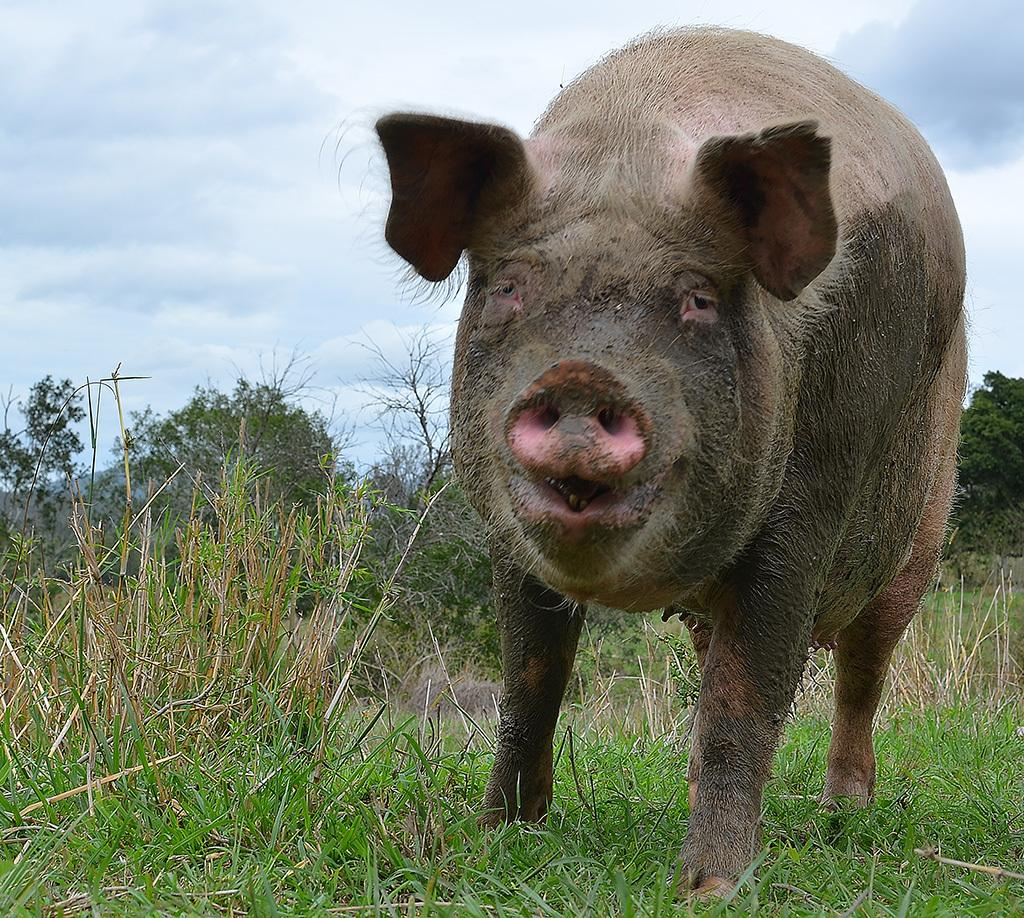What animal is present in the image? There is a pig in the image. What can be seen in the background of the image? There are trees in the background of the image. What is visible at the bottom of the image? The ground is visible at the bottom of the image. What type of vegetation covers the ground in the image? The ground is covered with grass. How many wings does the pig have in the image? The pig does not have any wings in the image, as pigs are not known to have wings. 